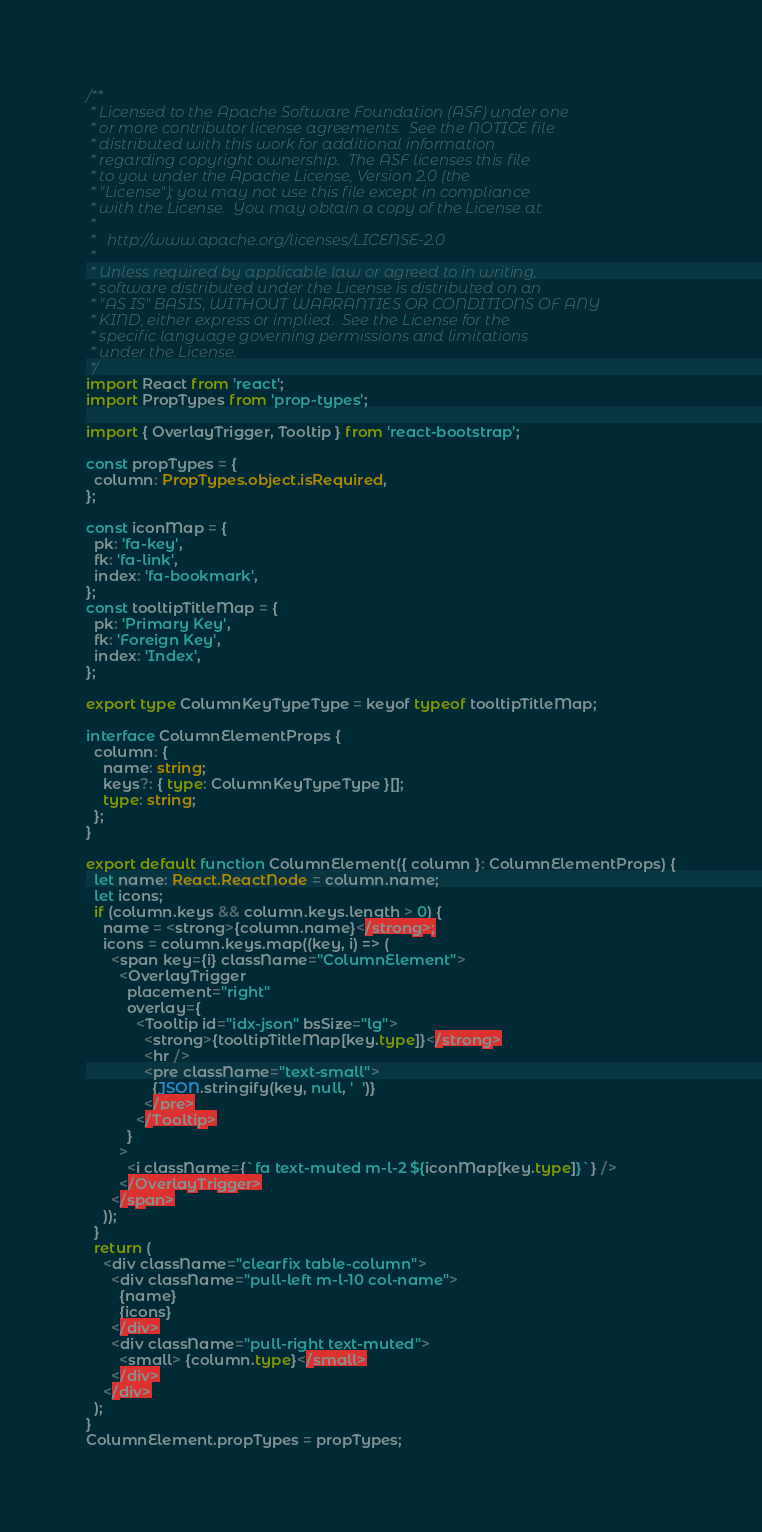<code> <loc_0><loc_0><loc_500><loc_500><_TypeScript_>/**
 * Licensed to the Apache Software Foundation (ASF) under one
 * or more contributor license agreements.  See the NOTICE file
 * distributed with this work for additional information
 * regarding copyright ownership.  The ASF licenses this file
 * to you under the Apache License, Version 2.0 (the
 * "License"); you may not use this file except in compliance
 * with the License.  You may obtain a copy of the License at
 *
 *   http://www.apache.org/licenses/LICENSE-2.0
 *
 * Unless required by applicable law or agreed to in writing,
 * software distributed under the License is distributed on an
 * "AS IS" BASIS, WITHOUT WARRANTIES OR CONDITIONS OF ANY
 * KIND, either express or implied.  See the License for the
 * specific language governing permissions and limitations
 * under the License.
 */
import React from 'react';
import PropTypes from 'prop-types';

import { OverlayTrigger, Tooltip } from 'react-bootstrap';

const propTypes = {
  column: PropTypes.object.isRequired,
};

const iconMap = {
  pk: 'fa-key',
  fk: 'fa-link',
  index: 'fa-bookmark',
};
const tooltipTitleMap = {
  pk: 'Primary Key',
  fk: 'Foreign Key',
  index: 'Index',
};

export type ColumnKeyTypeType = keyof typeof tooltipTitleMap;

interface ColumnElementProps {
  column: {
    name: string;
    keys?: { type: ColumnKeyTypeType }[];
    type: string;
  };
}

export default function ColumnElement({ column }: ColumnElementProps) {
  let name: React.ReactNode = column.name;
  let icons;
  if (column.keys && column.keys.length > 0) {
    name = <strong>{column.name}</strong>;
    icons = column.keys.map((key, i) => (
      <span key={i} className="ColumnElement">
        <OverlayTrigger
          placement="right"
          overlay={
            <Tooltip id="idx-json" bsSize="lg">
              <strong>{tooltipTitleMap[key.type]}</strong>
              <hr />
              <pre className="text-small">
                {JSON.stringify(key, null, '  ')}
              </pre>
            </Tooltip>
          }
        >
          <i className={`fa text-muted m-l-2 ${iconMap[key.type]}`} />
        </OverlayTrigger>
      </span>
    ));
  }
  return (
    <div className="clearfix table-column">
      <div className="pull-left m-l-10 col-name">
        {name}
        {icons}
      </div>
      <div className="pull-right text-muted">
        <small> {column.type}</small>
      </div>
    </div>
  );
}
ColumnElement.propTypes = propTypes;
</code> 